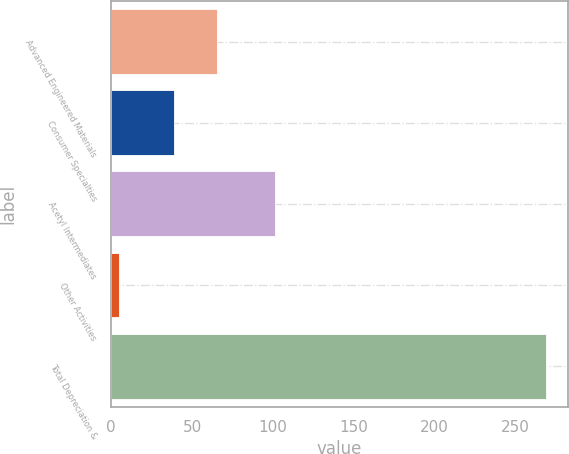Convert chart. <chart><loc_0><loc_0><loc_500><loc_500><bar_chart><fcel>Advanced Engineered Materials<fcel>Consumer Specialties<fcel>Acetyl Intermediates<fcel>Other Activities<fcel>Total Depreciation &<nl><fcel>65.4<fcel>39<fcel>101<fcel>5<fcel>269<nl></chart> 